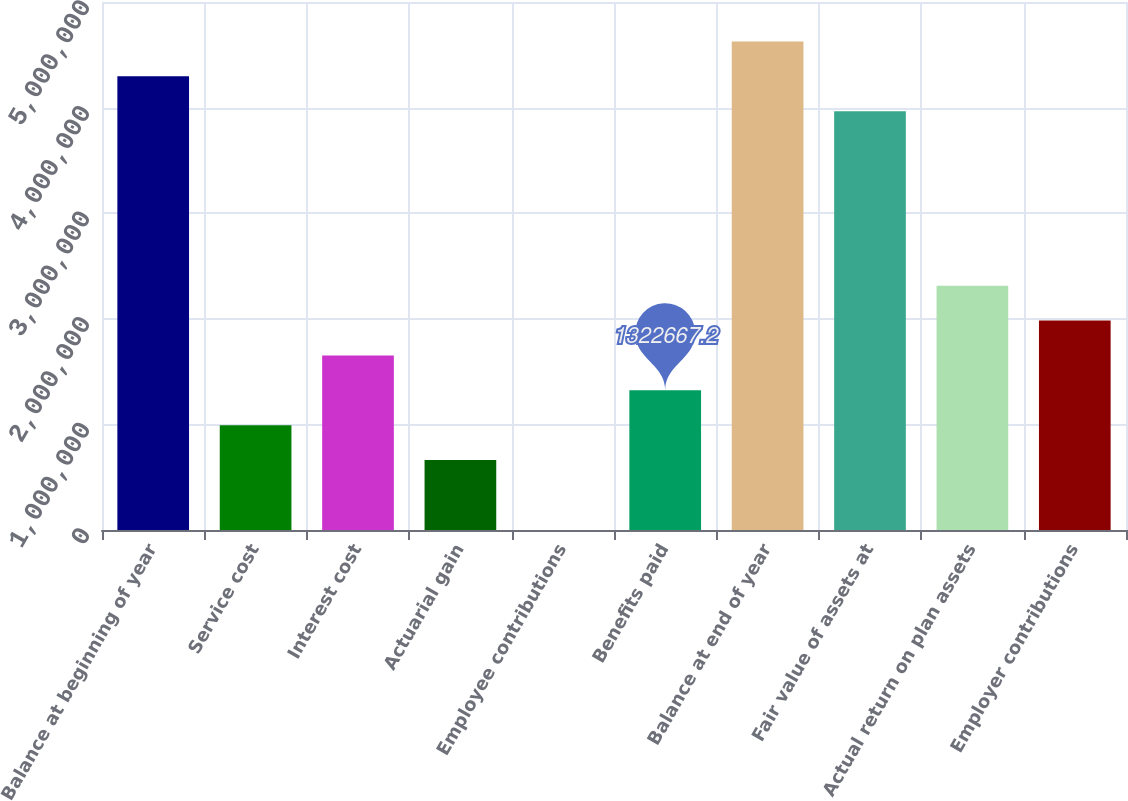Convert chart. <chart><loc_0><loc_0><loc_500><loc_500><bar_chart><fcel>Balance at beginning of year<fcel>Service cost<fcel>Interest cost<fcel>Actuarial gain<fcel>Employee contributions<fcel>Benefits paid<fcel>Balance at end of year<fcel>Fair value of assets at<fcel>Actual return on plan assets<fcel>Employer contributions<nl><fcel>4.29664e+06<fcel>992226<fcel>1.65311e+06<fcel>661785<fcel>902<fcel>1.32267e+06<fcel>4.62708e+06<fcel>3.9662e+06<fcel>2.31399e+06<fcel>1.98355e+06<nl></chart> 